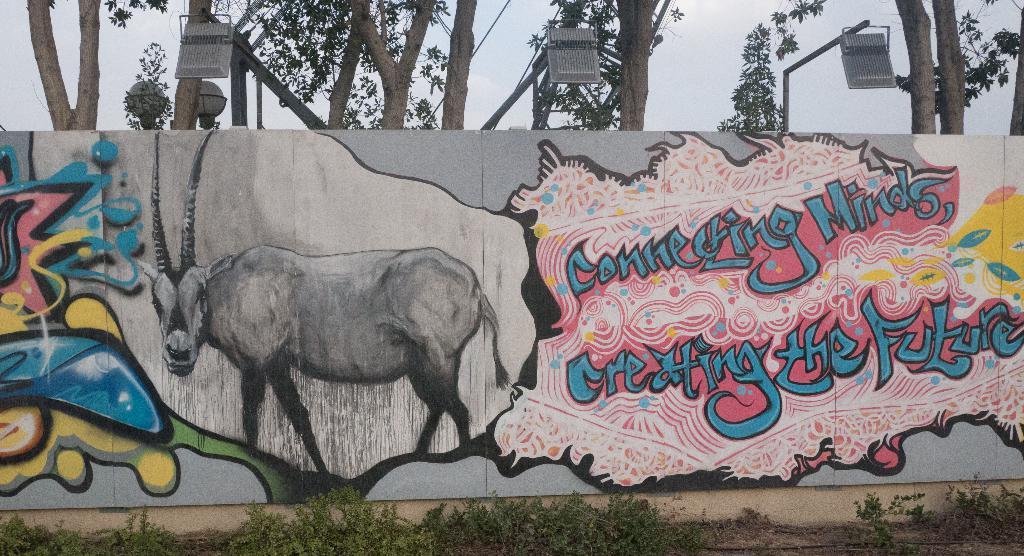Could you give a brief overview of what you see in this image? In this image there is a hoarding with text and pictures on the wall, on top of the hoarding there are focus lights and trees, in front of the hoarding there is grass. 